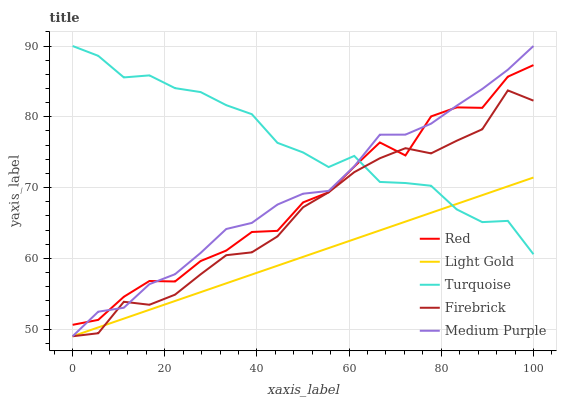Does Light Gold have the minimum area under the curve?
Answer yes or no. Yes. Does Turquoise have the maximum area under the curve?
Answer yes or no. Yes. Does Turquoise have the minimum area under the curve?
Answer yes or no. No. Does Light Gold have the maximum area under the curve?
Answer yes or no. No. Is Light Gold the smoothest?
Answer yes or no. Yes. Is Red the roughest?
Answer yes or no. Yes. Is Turquoise the smoothest?
Answer yes or no. No. Is Turquoise the roughest?
Answer yes or no. No. Does Medium Purple have the lowest value?
Answer yes or no. Yes. Does Turquoise have the lowest value?
Answer yes or no. No. Does Turquoise have the highest value?
Answer yes or no. Yes. Does Light Gold have the highest value?
Answer yes or no. No. Is Light Gold less than Red?
Answer yes or no. Yes. Is Red greater than Light Gold?
Answer yes or no. Yes. Does Light Gold intersect Firebrick?
Answer yes or no. Yes. Is Light Gold less than Firebrick?
Answer yes or no. No. Is Light Gold greater than Firebrick?
Answer yes or no. No. Does Light Gold intersect Red?
Answer yes or no. No. 